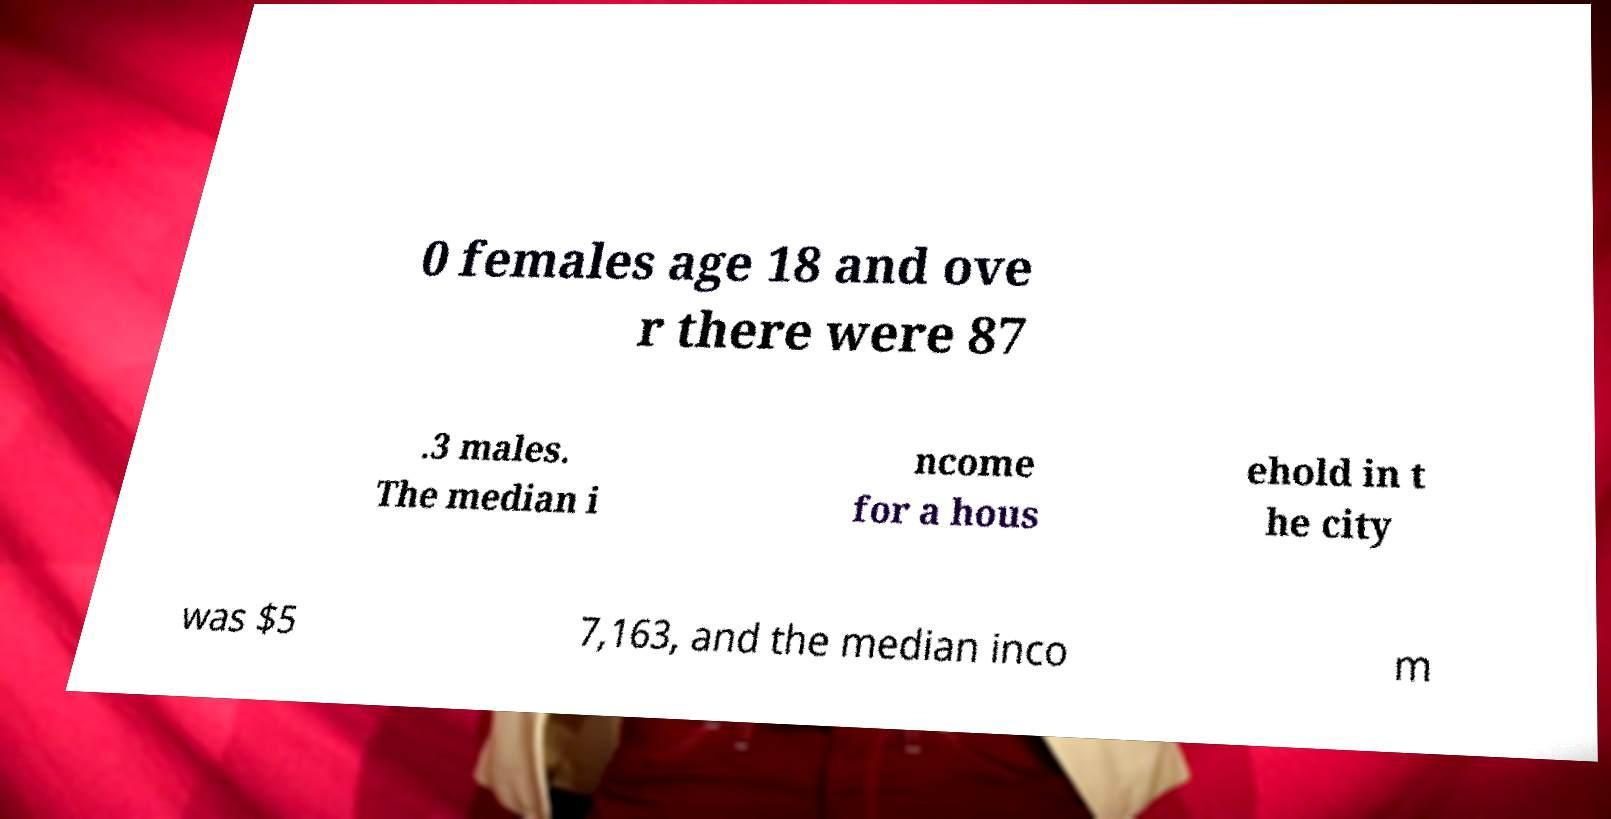Could you assist in decoding the text presented in this image and type it out clearly? 0 females age 18 and ove r there were 87 .3 males. The median i ncome for a hous ehold in t he city was $5 7,163, and the median inco m 